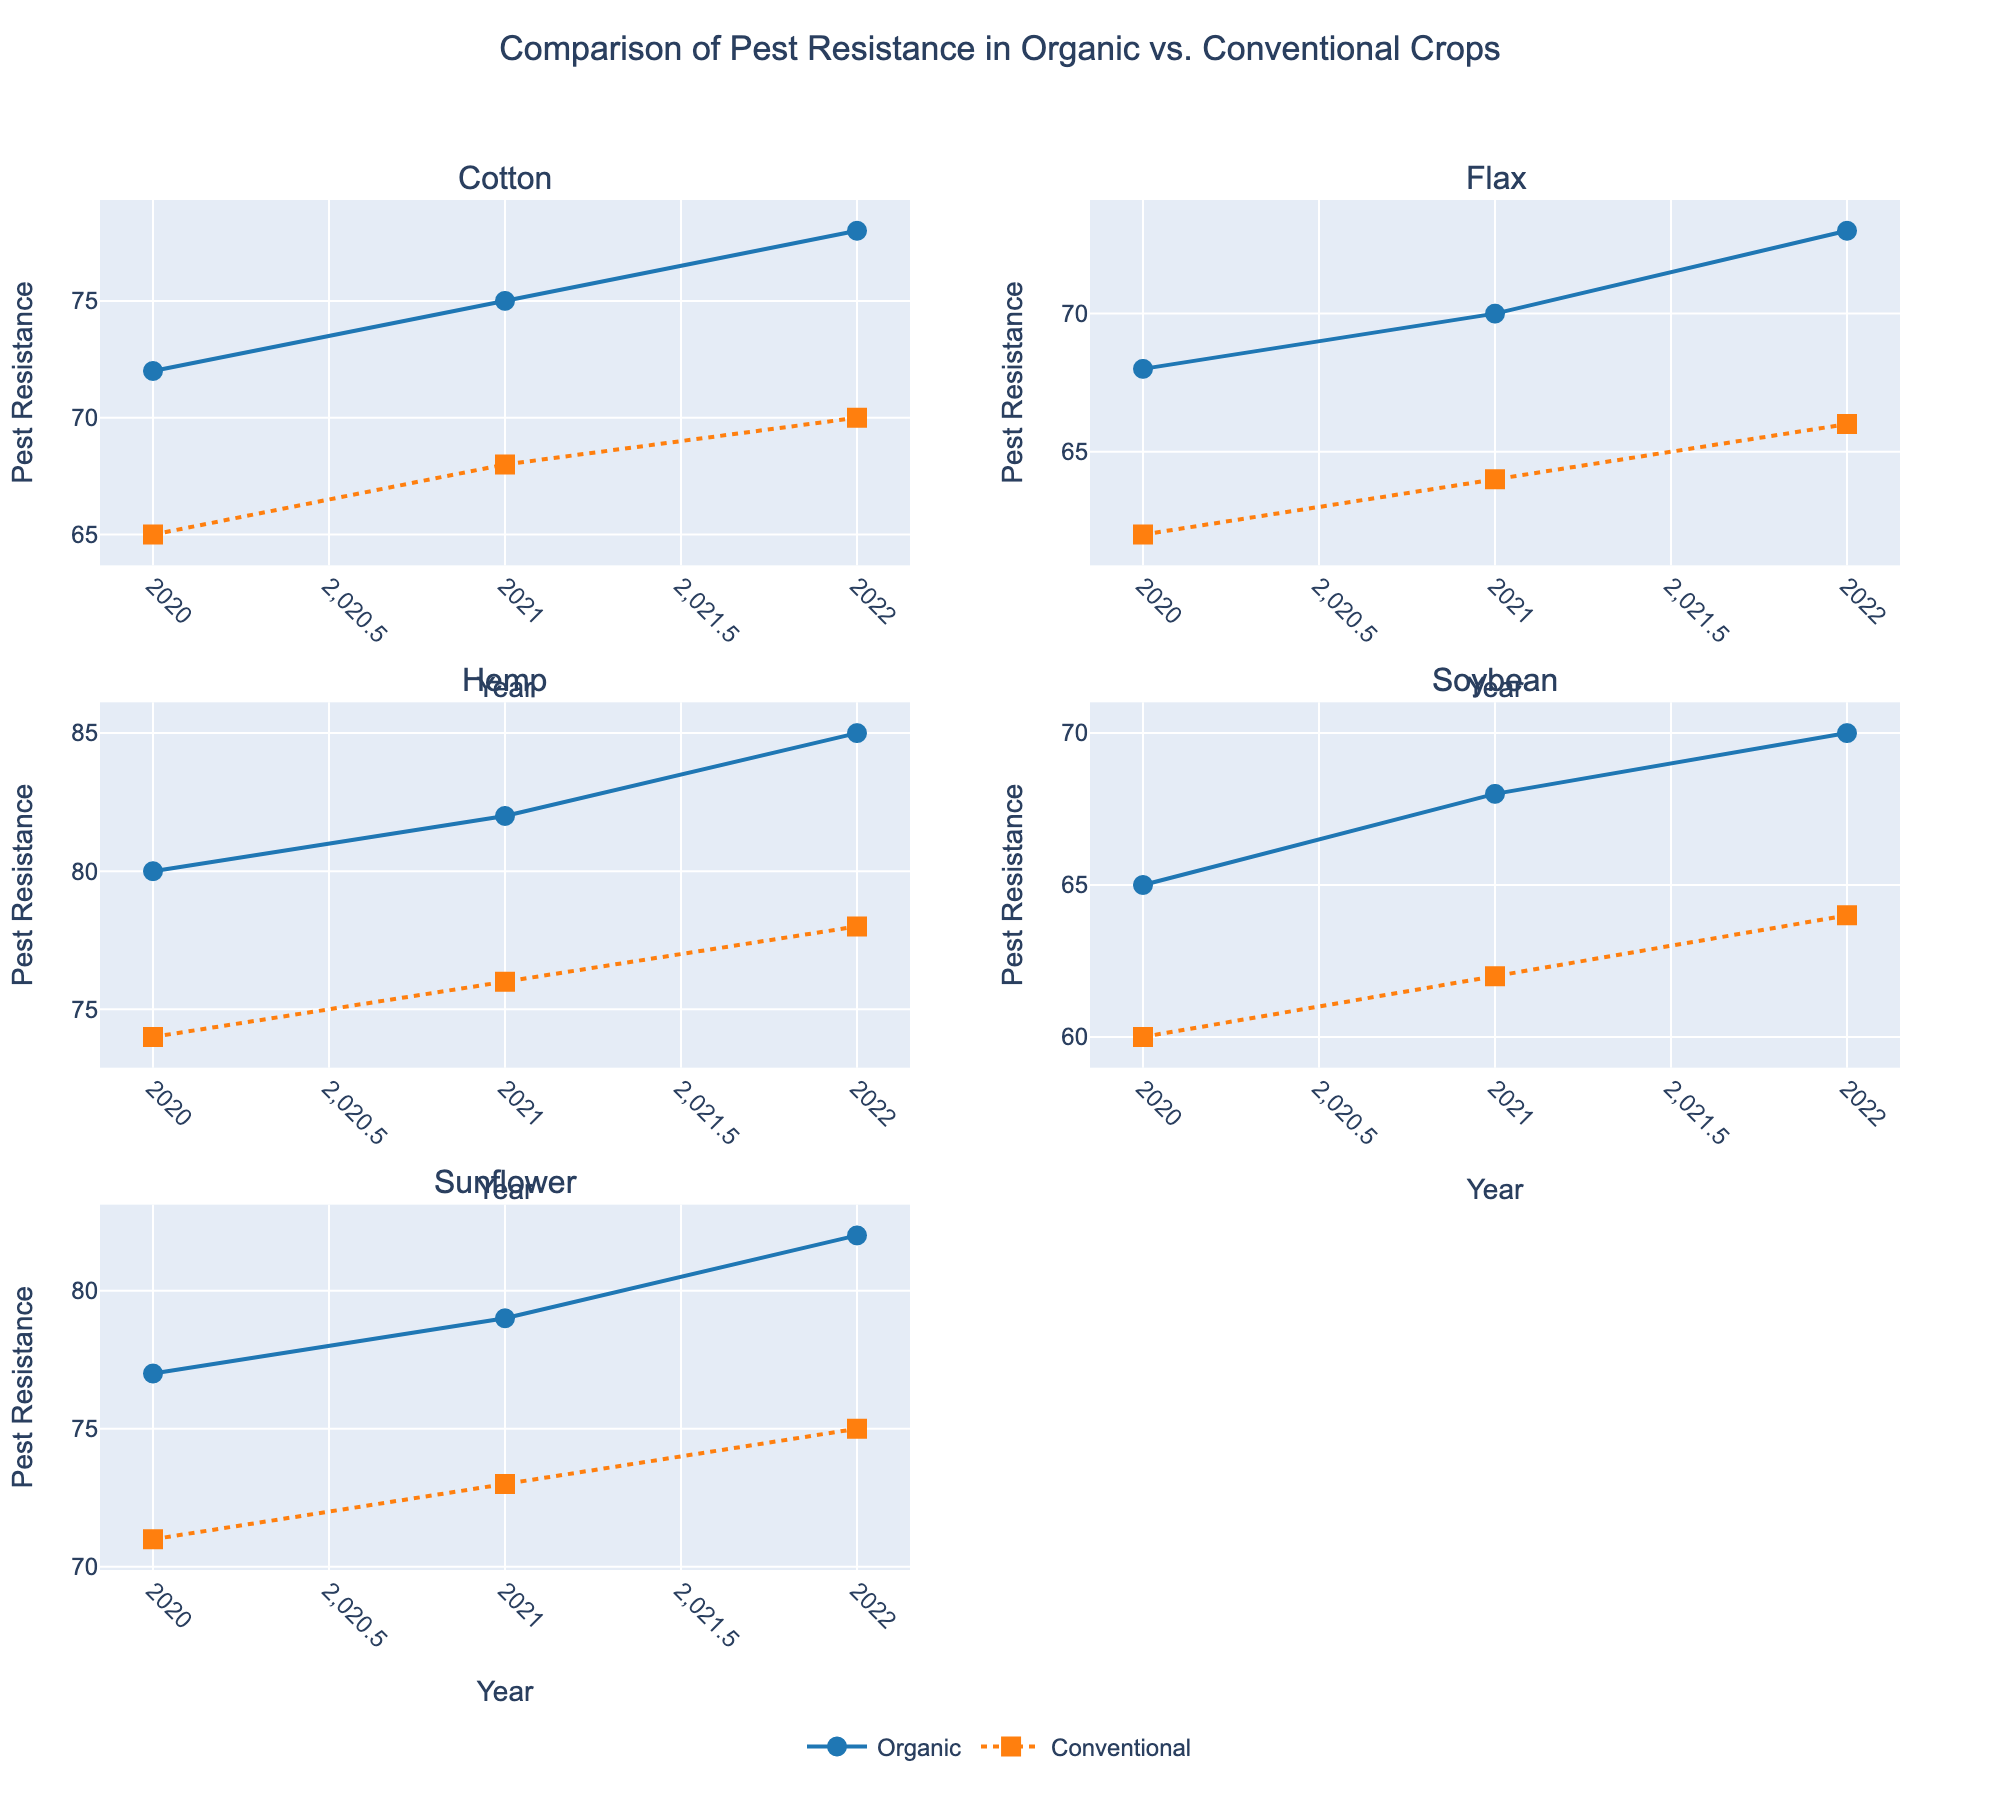Which crop shows the greatest increase in organic pest resistance from 2020 to 2022? To determine this, calculate the difference in organic pest resistance values for each crop from 2020 to 2022 and compare these differences. Cotton: 78 - 72 = 6, Flax: 73 - 68 = 5, Hemp: 85 - 80 = 5, Soybean: 70 - 65 = 5, Sunflower: 82 - 77 = 5. Cotton shows the greatest increase.
Answer: Cotton In 2022, which crop has the highest conventional pest resistance? Look at the values of conventional pest resistance in 2022 for all crops. Cotton: 70, Flax: 66, Hemp: 78, Soybean: 64, Sunflower: 75. Hemp has the highest value.
Answer: Hemp How does organic pest resistance in Sunflower in 2020 compare to Conventional pest resistance in Flax in 2022? Check the values: Organic pest resistance in Sunflower in 2020 is 77. Conventional pest resistance in Flax in 2022 is 66. Comparing both values, Sunflower has a higher resistance value than Flax.
Answer: Sunflower is higher What is the overall trend in pest resistance for organic crops from 2020 to 2022? Observe the trends in the lines for organic pest resistance across the years for each crop. All the lines are increasing. Therefore, the overall trend shows an increase in pest resistance for organic crops from 2020 to 2022.
Answer: Increasing Which crop has the closest pest resistance value between organic and conventional methods in 2020? Look at the pest resistance values for both methods in 2020: Cotton: Org - 72, Conv - 65; Flax: Org - 68, Conv - 62; Hemp: Org - 80, Conv - 74; Soybean: Org - 65, Conv - 60; Sunflower: Org - 77, Conv - 71. Calculate the differences: Cotton: 7, Flax: 6, Hemp: 6, Soybean: 5, Sunflower: 6. Soybean has the closest values.
Answer: Soybean Is there any crop where organic pest resistance is consistently higher than conventional pest resistance over all three years? Compare the organic and conventional pest resistance values for each year for each crop. All crops (Cotton, Flax, Hemp, Soybean, Sunflower) have higher organic pest resistance than conventional in each year.
Answer: All crops Which crops showed a parallel trend between the organic and conventional pest resistance from 2020 to 2022? Look at the lines for both organic and conventional pest resistance for each crop. Both lines for Hemp and Flax moved parallelly, indicating similar trends.
Answer: Hemp, Flax 